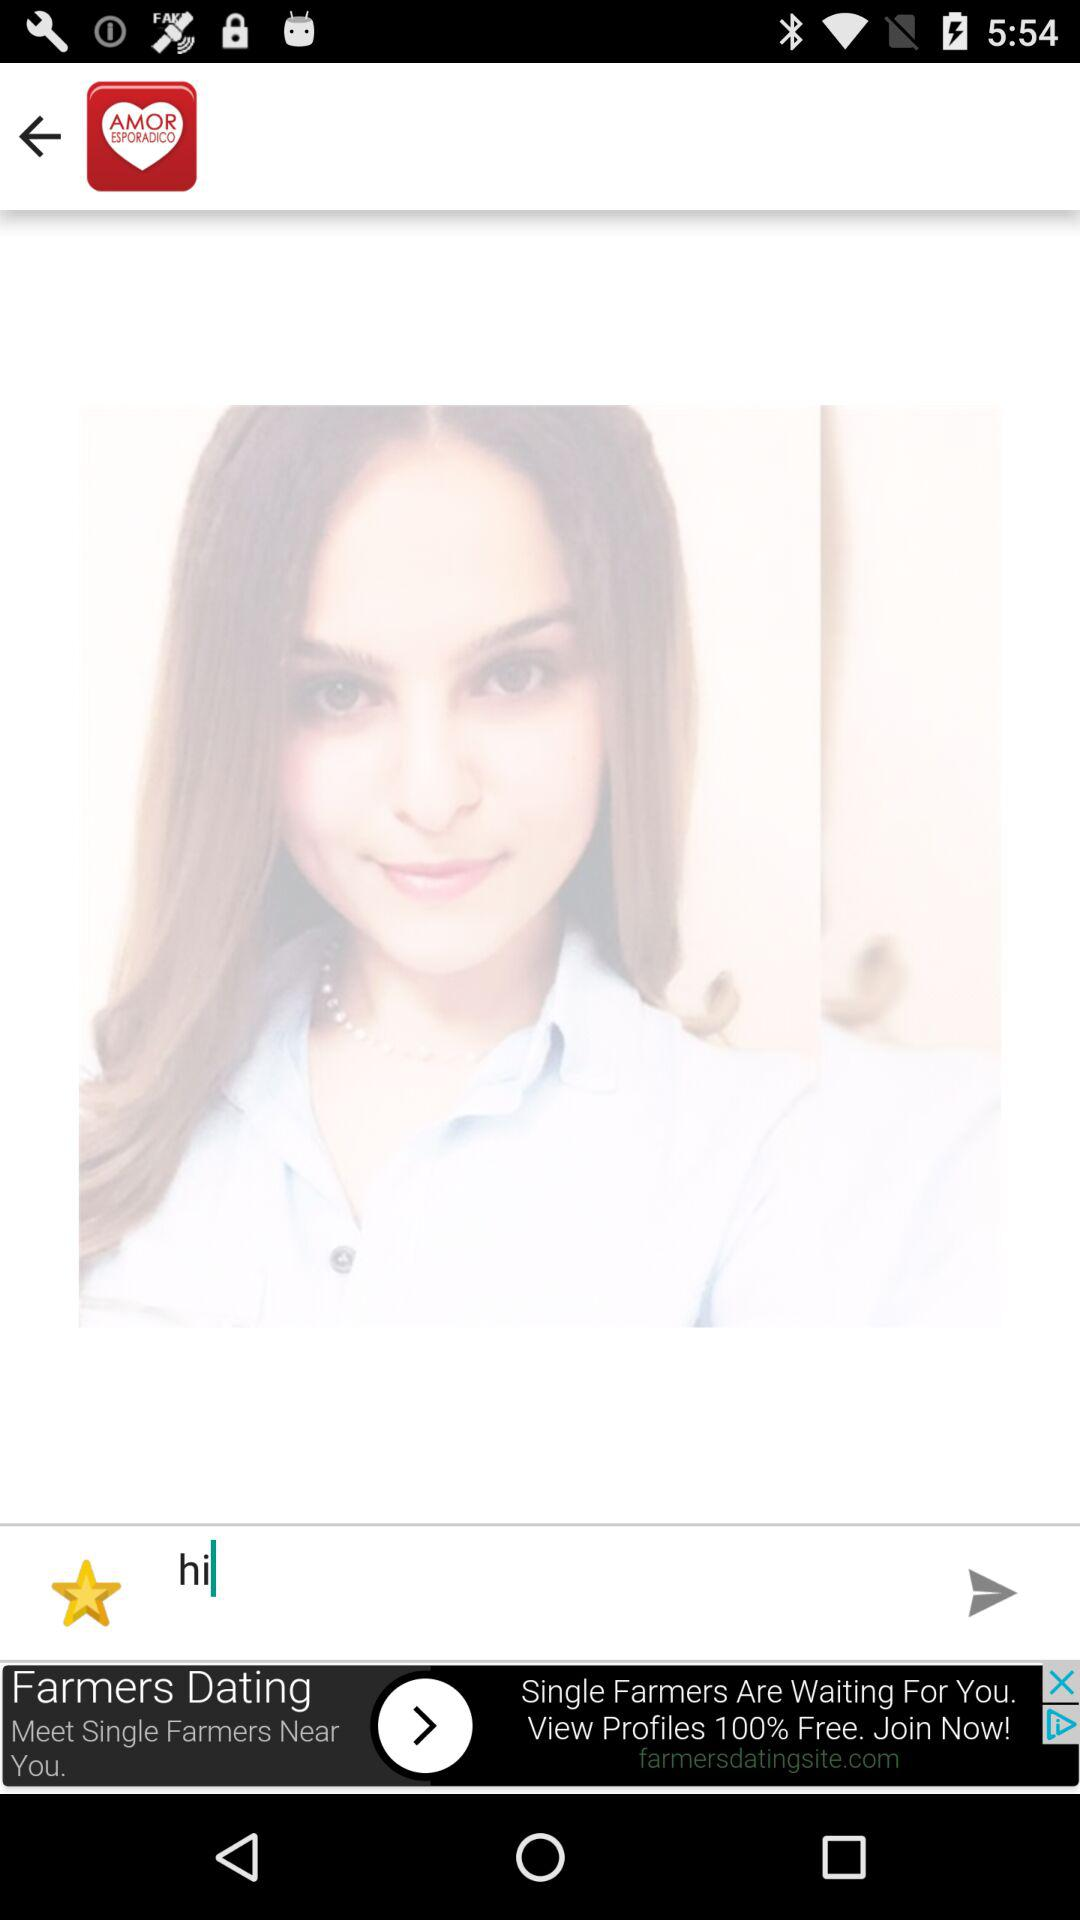How old is the user?
When the provided information is insufficient, respond with <no answer>. <no answer> 